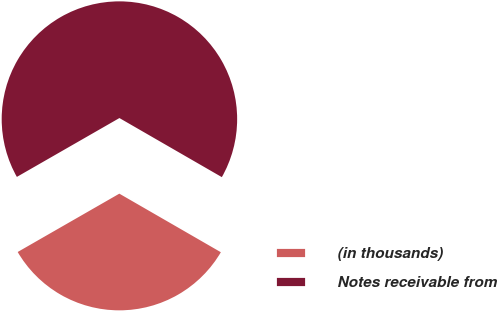Convert chart. <chart><loc_0><loc_0><loc_500><loc_500><pie_chart><fcel>(in thousands)<fcel>Notes receivable from<nl><fcel>33.38%<fcel>66.62%<nl></chart> 